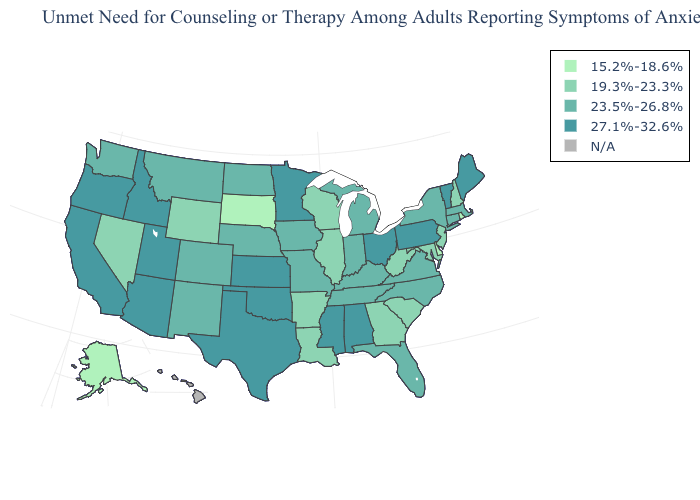Does the first symbol in the legend represent the smallest category?
Be succinct. Yes. How many symbols are there in the legend?
Be succinct. 5. Does New Hampshire have the lowest value in the USA?
Keep it brief. No. Name the states that have a value in the range N/A?
Keep it brief. Hawaii. Name the states that have a value in the range 23.5%-26.8%?
Write a very short answer. Colorado, Connecticut, Florida, Indiana, Iowa, Kentucky, Massachusetts, Michigan, Missouri, Montana, Nebraska, New Mexico, New York, North Carolina, North Dakota, Tennessee, Virginia, Washington. Name the states that have a value in the range N/A?
Quick response, please. Hawaii. Name the states that have a value in the range 15.2%-18.6%?
Quick response, please. Alaska, Delaware, Rhode Island, South Dakota. What is the highest value in the MidWest ?
Answer briefly. 27.1%-32.6%. What is the value of Wisconsin?
Be succinct. 19.3%-23.3%. Does the first symbol in the legend represent the smallest category?
Quick response, please. Yes. Does Alaska have the lowest value in the West?
Write a very short answer. Yes. What is the highest value in the West ?
Keep it brief. 27.1%-32.6%. What is the value of New Mexico?
Be succinct. 23.5%-26.8%. 